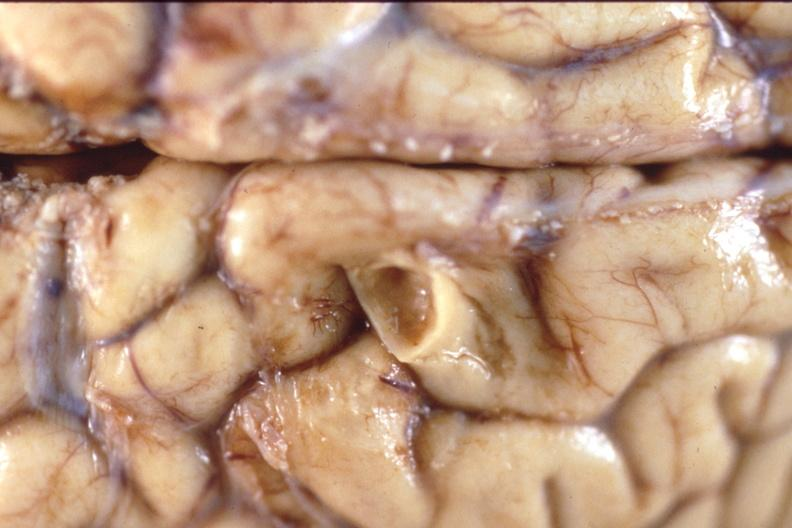does this image show brain, breast cancer metastasis to meninges?
Answer the question using a single word or phrase. Yes 